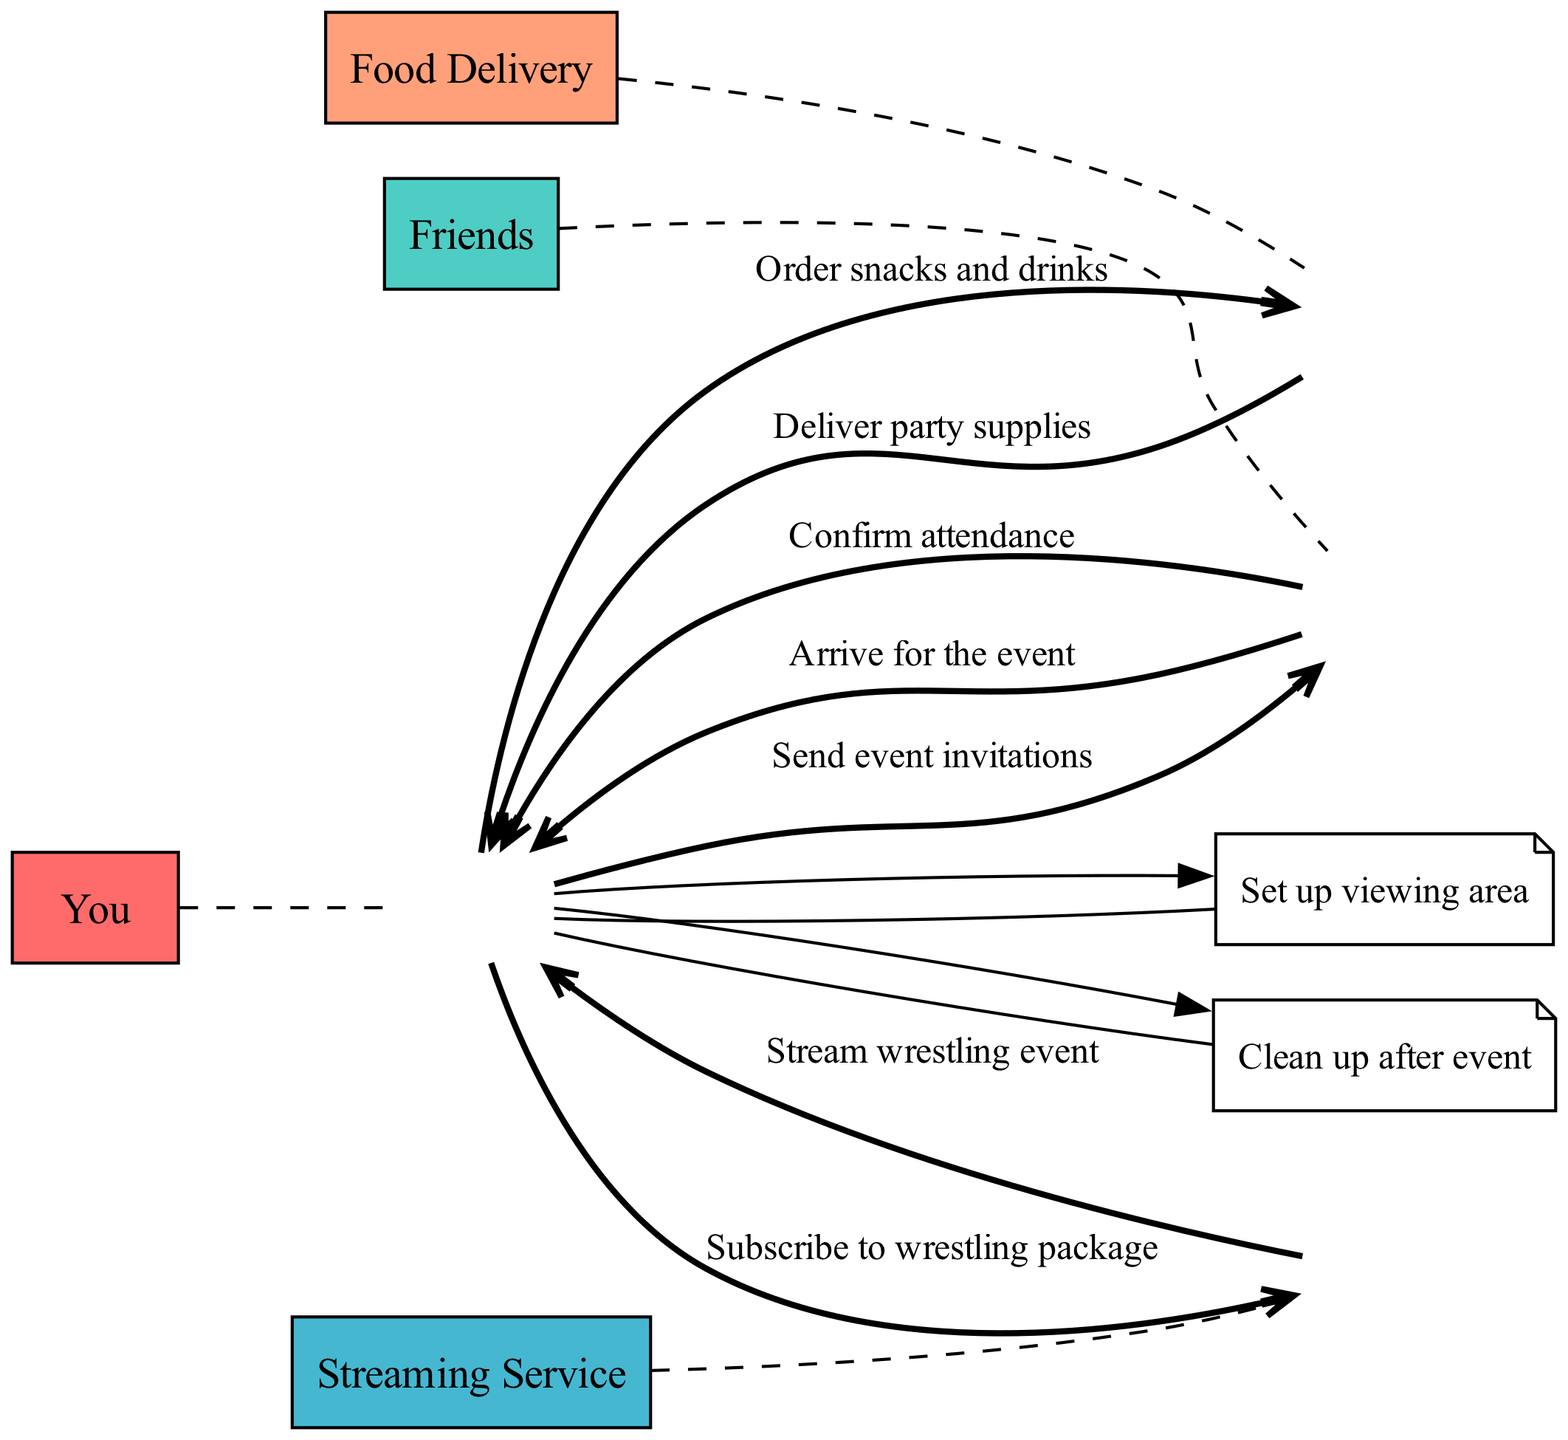What is the first action in the sequence? The first action in the sequence is the sending of event invitations initiated by "You" to "Friends". This is clear from the first entry of the sequence list where "You" interacts with "Friends".
Answer: Send event invitations How many actors are involved in this sequence? To determine the number of actors, we can count each unique actor listed in the sequence. There are four actors mentioned: "You", "Friends", "Streaming Service", and "Food Delivery".
Answer: Four What action occurs after "Confirm attendance"? After "Confirm attendance" from "Friends" to "You", the next action is for "You" to subscribe to the wrestling package with the "Streaming Service". This is the direct next entry in the sequence following the confirmation.
Answer: Subscribe to wrestling package Who delivers the party supplies? The party supplies are delivered by "Food Delivery" to "You". This is indicated in the sequence where the delivery action is specified from "Food Delivery" to "You".
Answer: Food Delivery What is the final action that happens in the sequence? The final action in the sequence is "Clean up after event" performed by "You", as indicated by the last entry in the sequence which refers to actions taken by "You" post-event.
Answer: Clean up after event Which actor is responsible for ordering snacks and drinks? The actor responsible for ordering snacks and drinks is "You". This can be seen in the sequence where the action of ordering is initiated by "You" directed to "Food Delivery".
Answer: You How many actions are performed by "You"? To find out how many actions "You" perform, we can count the interactions involving "You". Analyzing the sequence, "You" have five actions: sending invitations, subscribing, ordering snacks, setting up the area, and cleaning up.
Answer: Five Which action follows the "Arrive for the event"? The action that follows "Arrive for the event" is "Stream wrestling event" from the "Streaming Service" to "You". This can be deduced by looking at the sequence order directly after the friends arrive.
Answer: Stream wrestling event 